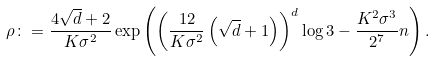Convert formula to latex. <formula><loc_0><loc_0><loc_500><loc_500>\rho \colon = \frac { 4 \sqrt { d } + 2 } { K \sigma ^ { 2 } } \exp \left ( \left ( \frac { 1 2 } { K \sigma ^ { 2 } } \left ( \sqrt { d } + 1 \right ) \right ) ^ { d } \log 3 - \frac { K ^ { 2 } \sigma ^ { 3 } } { 2 ^ { 7 } } n \right ) .</formula> 